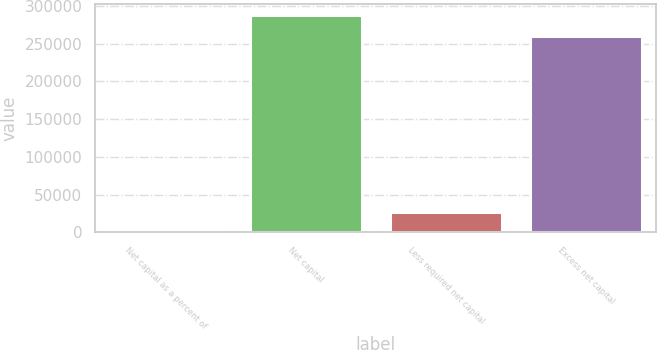<chart> <loc_0><loc_0><loc_500><loc_500><bar_chart><fcel>Net capital as a percent of<fcel>Net capital<fcel>Less required net capital<fcel>Excess net capital<nl><fcel>58.48<fcel>287768<fcel>27093.9<fcel>260733<nl></chart> 